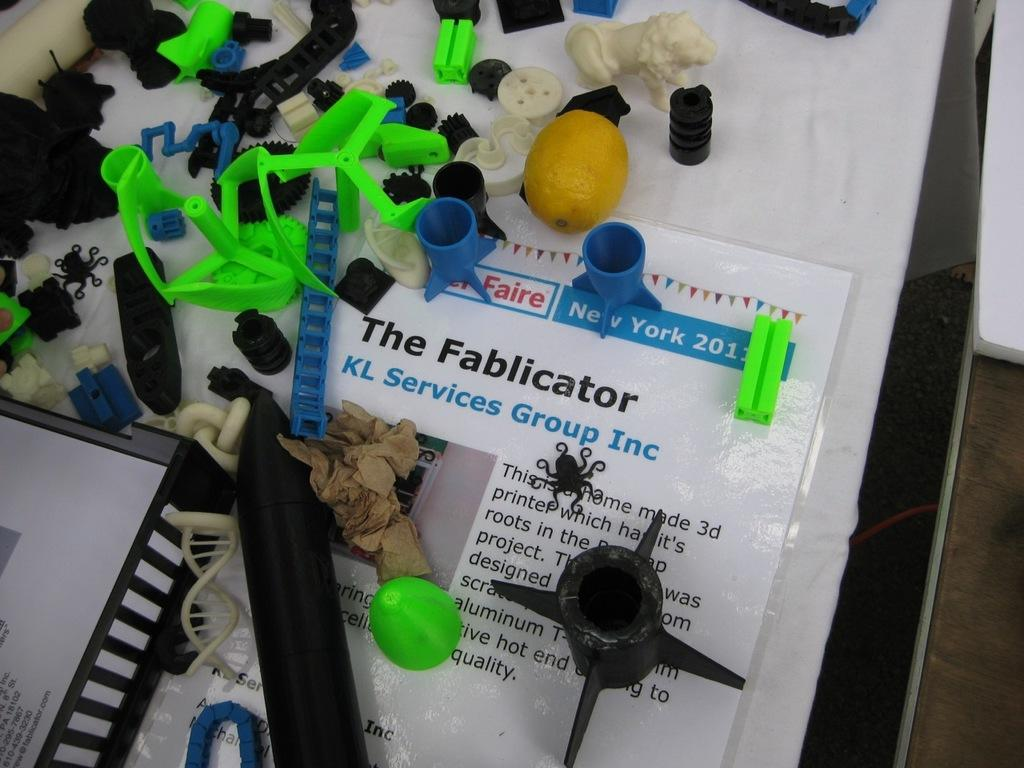What is placed on the table in the image? There is a paper, a cloth, balls, a lemon, toys, a statue of a lion, and caps on the table. What type of objects are present on the table? There are balls, a lemon, toys, a statue of a lion, and caps on the table. Can you describe the statue on the table? There is a statue of a lion on the table. What other objects can be seen on the table? There are other objects on the table, but their specific details are not mentioned in the provided facts. How does the icicle on the table affect the temperature in the room? There is no icicle present on the table in the image, so it cannot affect the temperature in the room. 